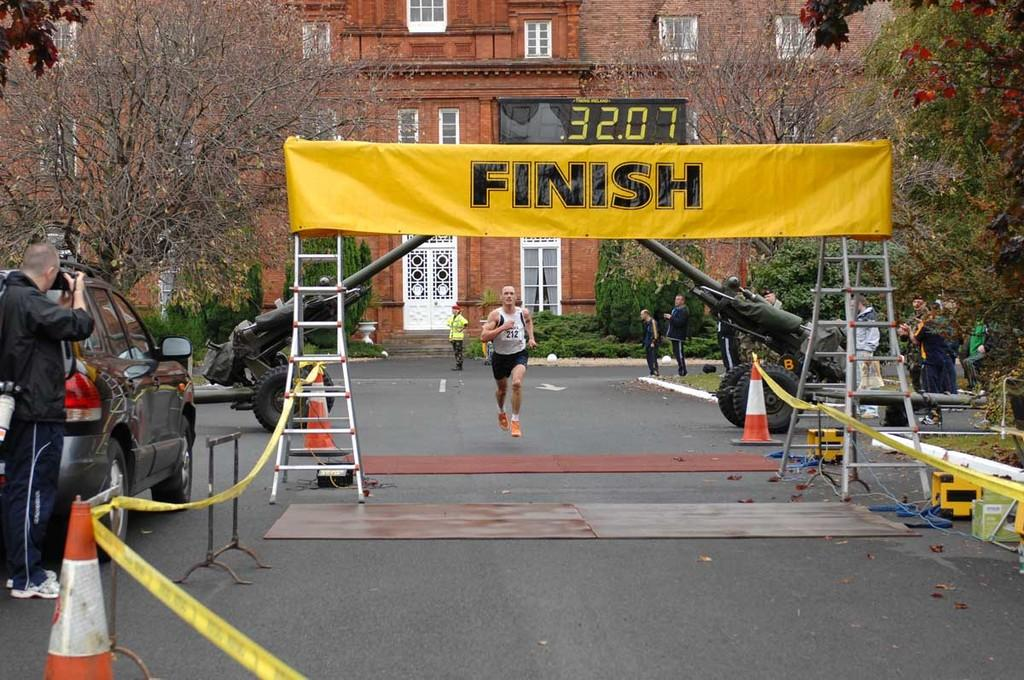Provide a one-sentence caption for the provided image. Man is running on the road headed to the finish line. 